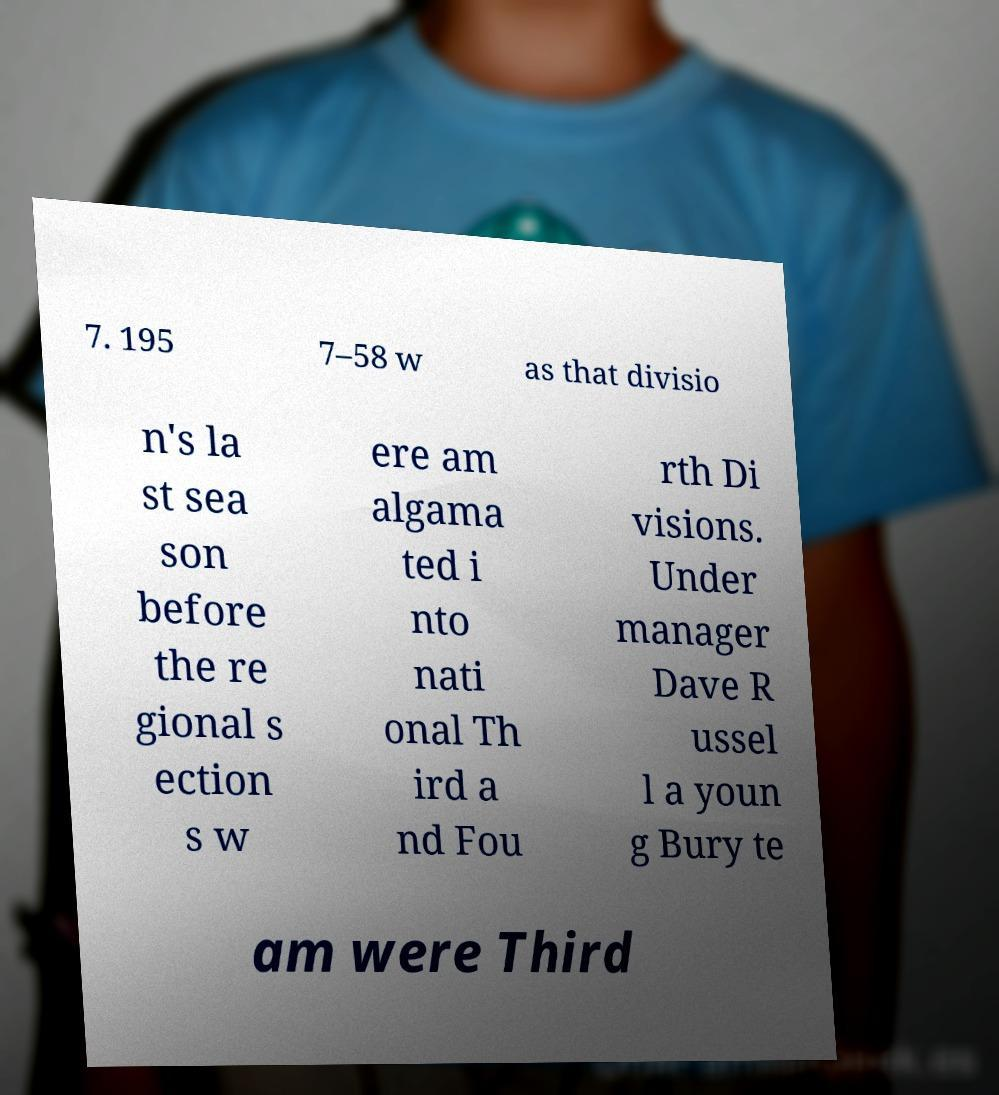Could you extract and type out the text from this image? 7. 195 7–58 w as that divisio n's la st sea son before the re gional s ection s w ere am algama ted i nto nati onal Th ird a nd Fou rth Di visions. Under manager Dave R ussel l a youn g Bury te am were Third 